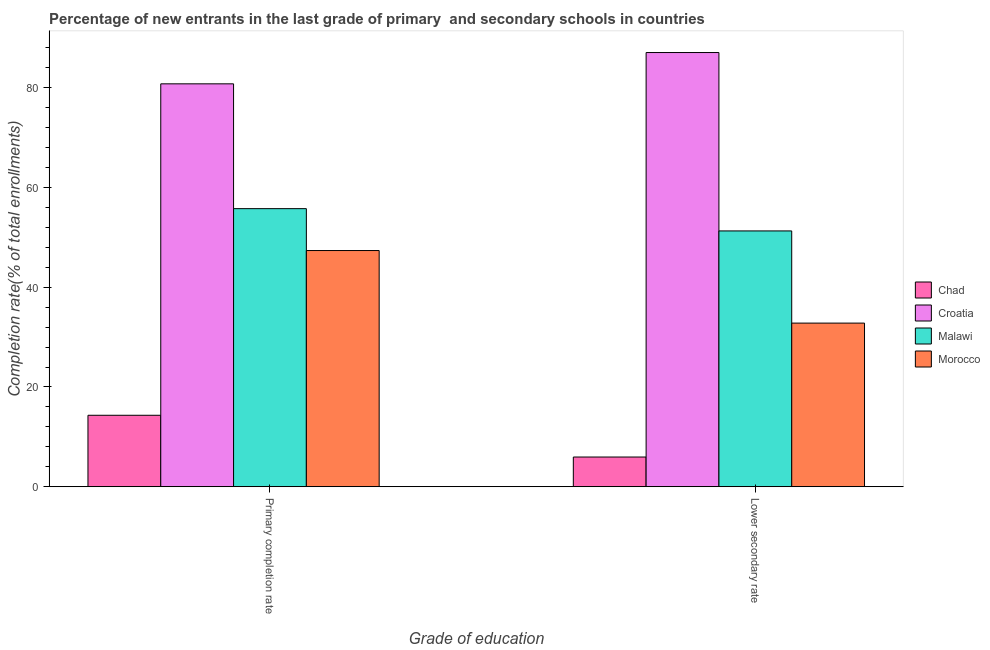Are the number of bars per tick equal to the number of legend labels?
Provide a short and direct response. Yes. How many bars are there on the 2nd tick from the left?
Provide a succinct answer. 4. What is the label of the 1st group of bars from the left?
Give a very brief answer. Primary completion rate. What is the completion rate in secondary schools in Chad?
Your answer should be very brief. 5.96. Across all countries, what is the maximum completion rate in secondary schools?
Make the answer very short. 87.07. Across all countries, what is the minimum completion rate in secondary schools?
Make the answer very short. 5.96. In which country was the completion rate in secondary schools maximum?
Ensure brevity in your answer.  Croatia. In which country was the completion rate in primary schools minimum?
Your answer should be compact. Chad. What is the total completion rate in primary schools in the graph?
Your answer should be compact. 198.25. What is the difference between the completion rate in secondary schools in Croatia and that in Malawi?
Provide a succinct answer. 35.77. What is the difference between the completion rate in primary schools in Chad and the completion rate in secondary schools in Morocco?
Your response must be concise. -18.48. What is the average completion rate in primary schools per country?
Your answer should be compact. 49.56. What is the difference between the completion rate in primary schools and completion rate in secondary schools in Chad?
Provide a succinct answer. 8.37. In how many countries, is the completion rate in primary schools greater than 72 %?
Give a very brief answer. 1. What is the ratio of the completion rate in primary schools in Malawi to that in Chad?
Keep it short and to the point. 3.89. Is the completion rate in secondary schools in Morocco less than that in Malawi?
Your answer should be compact. Yes. What does the 4th bar from the left in Primary completion rate represents?
Keep it short and to the point. Morocco. What does the 2nd bar from the right in Lower secondary rate represents?
Offer a very short reply. Malawi. Are all the bars in the graph horizontal?
Your response must be concise. No. What is the difference between two consecutive major ticks on the Y-axis?
Provide a short and direct response. 20. Does the graph contain any zero values?
Your answer should be very brief. No. Where does the legend appear in the graph?
Your response must be concise. Center right. How are the legend labels stacked?
Give a very brief answer. Vertical. What is the title of the graph?
Your answer should be very brief. Percentage of new entrants in the last grade of primary  and secondary schools in countries. Does "Romania" appear as one of the legend labels in the graph?
Offer a very short reply. No. What is the label or title of the X-axis?
Offer a very short reply. Grade of education. What is the label or title of the Y-axis?
Provide a short and direct response. Completion rate(% of total enrollments). What is the Completion rate(% of total enrollments) in Chad in Primary completion rate?
Provide a succinct answer. 14.33. What is the Completion rate(% of total enrollments) of Croatia in Primary completion rate?
Offer a terse response. 80.79. What is the Completion rate(% of total enrollments) of Malawi in Primary completion rate?
Provide a short and direct response. 55.76. What is the Completion rate(% of total enrollments) in Morocco in Primary completion rate?
Your response must be concise. 47.36. What is the Completion rate(% of total enrollments) of Chad in Lower secondary rate?
Your response must be concise. 5.96. What is the Completion rate(% of total enrollments) of Croatia in Lower secondary rate?
Offer a terse response. 87.07. What is the Completion rate(% of total enrollments) in Malawi in Lower secondary rate?
Ensure brevity in your answer.  51.29. What is the Completion rate(% of total enrollments) in Morocco in Lower secondary rate?
Offer a very short reply. 32.81. Across all Grade of education, what is the maximum Completion rate(% of total enrollments) in Chad?
Provide a short and direct response. 14.33. Across all Grade of education, what is the maximum Completion rate(% of total enrollments) in Croatia?
Your response must be concise. 87.07. Across all Grade of education, what is the maximum Completion rate(% of total enrollments) of Malawi?
Offer a very short reply. 55.76. Across all Grade of education, what is the maximum Completion rate(% of total enrollments) in Morocco?
Make the answer very short. 47.36. Across all Grade of education, what is the minimum Completion rate(% of total enrollments) in Chad?
Make the answer very short. 5.96. Across all Grade of education, what is the minimum Completion rate(% of total enrollments) in Croatia?
Your answer should be compact. 80.79. Across all Grade of education, what is the minimum Completion rate(% of total enrollments) in Malawi?
Your answer should be compact. 51.29. Across all Grade of education, what is the minimum Completion rate(% of total enrollments) in Morocco?
Your answer should be compact. 32.81. What is the total Completion rate(% of total enrollments) in Chad in the graph?
Offer a very short reply. 20.28. What is the total Completion rate(% of total enrollments) in Croatia in the graph?
Offer a terse response. 167.86. What is the total Completion rate(% of total enrollments) in Malawi in the graph?
Keep it short and to the point. 107.06. What is the total Completion rate(% of total enrollments) of Morocco in the graph?
Provide a short and direct response. 80.17. What is the difference between the Completion rate(% of total enrollments) of Chad in Primary completion rate and that in Lower secondary rate?
Your answer should be compact. 8.37. What is the difference between the Completion rate(% of total enrollments) in Croatia in Primary completion rate and that in Lower secondary rate?
Ensure brevity in your answer.  -6.28. What is the difference between the Completion rate(% of total enrollments) in Malawi in Primary completion rate and that in Lower secondary rate?
Provide a short and direct response. 4.47. What is the difference between the Completion rate(% of total enrollments) in Morocco in Primary completion rate and that in Lower secondary rate?
Provide a succinct answer. 14.55. What is the difference between the Completion rate(% of total enrollments) of Chad in Primary completion rate and the Completion rate(% of total enrollments) of Croatia in Lower secondary rate?
Offer a terse response. -72.74. What is the difference between the Completion rate(% of total enrollments) of Chad in Primary completion rate and the Completion rate(% of total enrollments) of Malawi in Lower secondary rate?
Offer a terse response. -36.96. What is the difference between the Completion rate(% of total enrollments) of Chad in Primary completion rate and the Completion rate(% of total enrollments) of Morocco in Lower secondary rate?
Offer a very short reply. -18.48. What is the difference between the Completion rate(% of total enrollments) in Croatia in Primary completion rate and the Completion rate(% of total enrollments) in Malawi in Lower secondary rate?
Offer a terse response. 29.5. What is the difference between the Completion rate(% of total enrollments) of Croatia in Primary completion rate and the Completion rate(% of total enrollments) of Morocco in Lower secondary rate?
Make the answer very short. 47.98. What is the difference between the Completion rate(% of total enrollments) of Malawi in Primary completion rate and the Completion rate(% of total enrollments) of Morocco in Lower secondary rate?
Your response must be concise. 22.95. What is the average Completion rate(% of total enrollments) of Chad per Grade of education?
Keep it short and to the point. 10.14. What is the average Completion rate(% of total enrollments) of Croatia per Grade of education?
Keep it short and to the point. 83.93. What is the average Completion rate(% of total enrollments) in Malawi per Grade of education?
Provide a succinct answer. 53.53. What is the average Completion rate(% of total enrollments) in Morocco per Grade of education?
Keep it short and to the point. 40.09. What is the difference between the Completion rate(% of total enrollments) in Chad and Completion rate(% of total enrollments) in Croatia in Primary completion rate?
Your response must be concise. -66.46. What is the difference between the Completion rate(% of total enrollments) in Chad and Completion rate(% of total enrollments) in Malawi in Primary completion rate?
Offer a terse response. -41.43. What is the difference between the Completion rate(% of total enrollments) in Chad and Completion rate(% of total enrollments) in Morocco in Primary completion rate?
Give a very brief answer. -33.03. What is the difference between the Completion rate(% of total enrollments) in Croatia and Completion rate(% of total enrollments) in Malawi in Primary completion rate?
Your answer should be compact. 25.03. What is the difference between the Completion rate(% of total enrollments) in Croatia and Completion rate(% of total enrollments) in Morocco in Primary completion rate?
Offer a very short reply. 33.43. What is the difference between the Completion rate(% of total enrollments) in Malawi and Completion rate(% of total enrollments) in Morocco in Primary completion rate?
Your answer should be very brief. 8.4. What is the difference between the Completion rate(% of total enrollments) of Chad and Completion rate(% of total enrollments) of Croatia in Lower secondary rate?
Ensure brevity in your answer.  -81.11. What is the difference between the Completion rate(% of total enrollments) of Chad and Completion rate(% of total enrollments) of Malawi in Lower secondary rate?
Keep it short and to the point. -45.34. What is the difference between the Completion rate(% of total enrollments) in Chad and Completion rate(% of total enrollments) in Morocco in Lower secondary rate?
Your answer should be compact. -26.85. What is the difference between the Completion rate(% of total enrollments) in Croatia and Completion rate(% of total enrollments) in Malawi in Lower secondary rate?
Make the answer very short. 35.77. What is the difference between the Completion rate(% of total enrollments) in Croatia and Completion rate(% of total enrollments) in Morocco in Lower secondary rate?
Ensure brevity in your answer.  54.26. What is the difference between the Completion rate(% of total enrollments) of Malawi and Completion rate(% of total enrollments) of Morocco in Lower secondary rate?
Make the answer very short. 18.48. What is the ratio of the Completion rate(% of total enrollments) of Chad in Primary completion rate to that in Lower secondary rate?
Give a very brief answer. 2.41. What is the ratio of the Completion rate(% of total enrollments) in Croatia in Primary completion rate to that in Lower secondary rate?
Provide a succinct answer. 0.93. What is the ratio of the Completion rate(% of total enrollments) of Malawi in Primary completion rate to that in Lower secondary rate?
Keep it short and to the point. 1.09. What is the ratio of the Completion rate(% of total enrollments) of Morocco in Primary completion rate to that in Lower secondary rate?
Offer a very short reply. 1.44. What is the difference between the highest and the second highest Completion rate(% of total enrollments) of Chad?
Provide a short and direct response. 8.37. What is the difference between the highest and the second highest Completion rate(% of total enrollments) in Croatia?
Your response must be concise. 6.28. What is the difference between the highest and the second highest Completion rate(% of total enrollments) in Malawi?
Ensure brevity in your answer.  4.47. What is the difference between the highest and the second highest Completion rate(% of total enrollments) of Morocco?
Your response must be concise. 14.55. What is the difference between the highest and the lowest Completion rate(% of total enrollments) in Chad?
Provide a short and direct response. 8.37. What is the difference between the highest and the lowest Completion rate(% of total enrollments) in Croatia?
Your answer should be compact. 6.28. What is the difference between the highest and the lowest Completion rate(% of total enrollments) of Malawi?
Provide a succinct answer. 4.47. What is the difference between the highest and the lowest Completion rate(% of total enrollments) in Morocco?
Give a very brief answer. 14.55. 